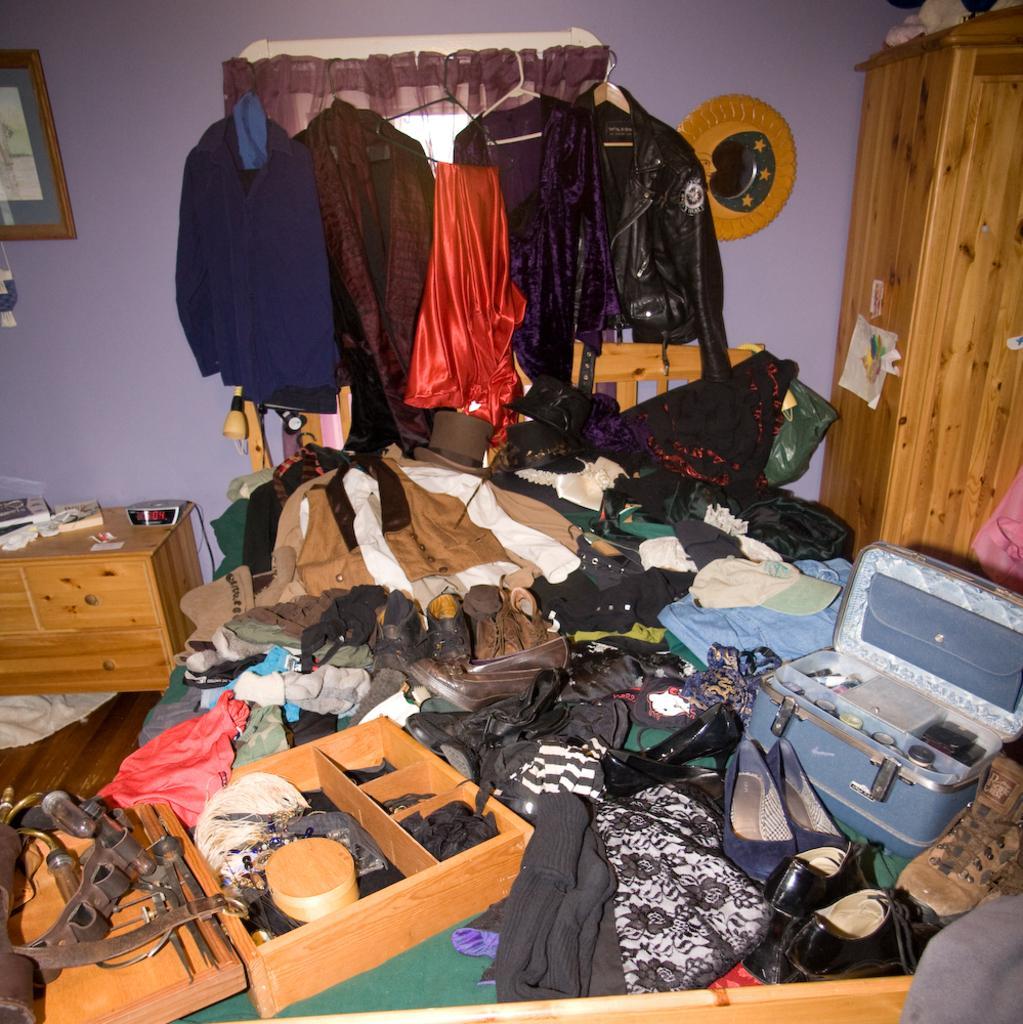Could you give a brief overview of what you see in this image? In this picture we can see clothes on the hanging rods. We can see a few objects on the wall. There are clothes, footwear, tools, wooden objects and other objects. 